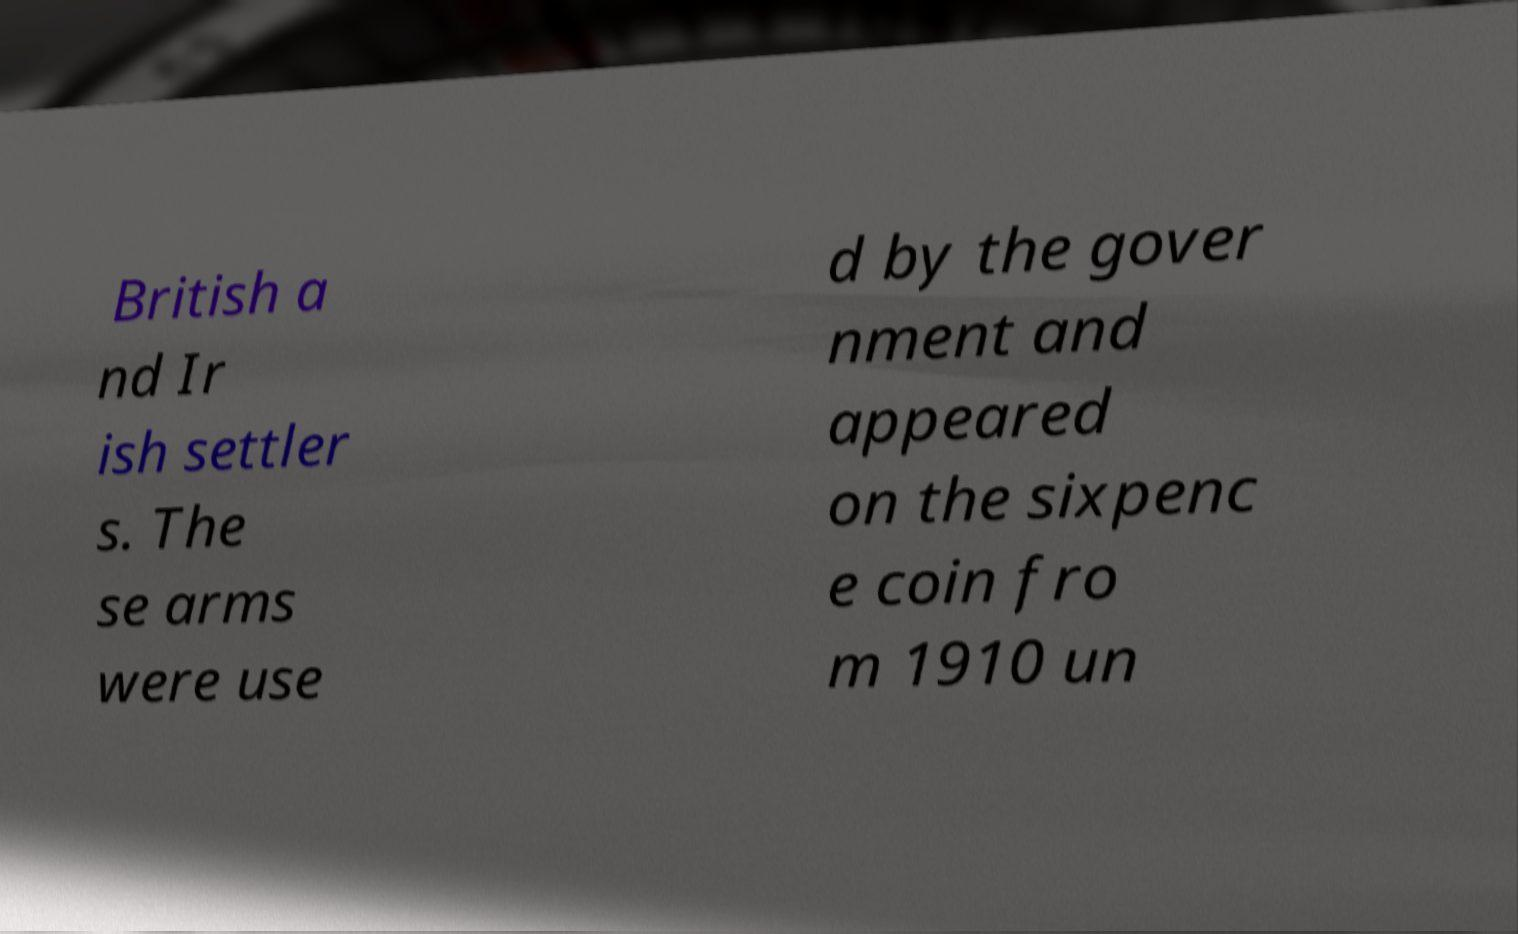Can you accurately transcribe the text from the provided image for me? British a nd Ir ish settler s. The se arms were use d by the gover nment and appeared on the sixpenc e coin fro m 1910 un 